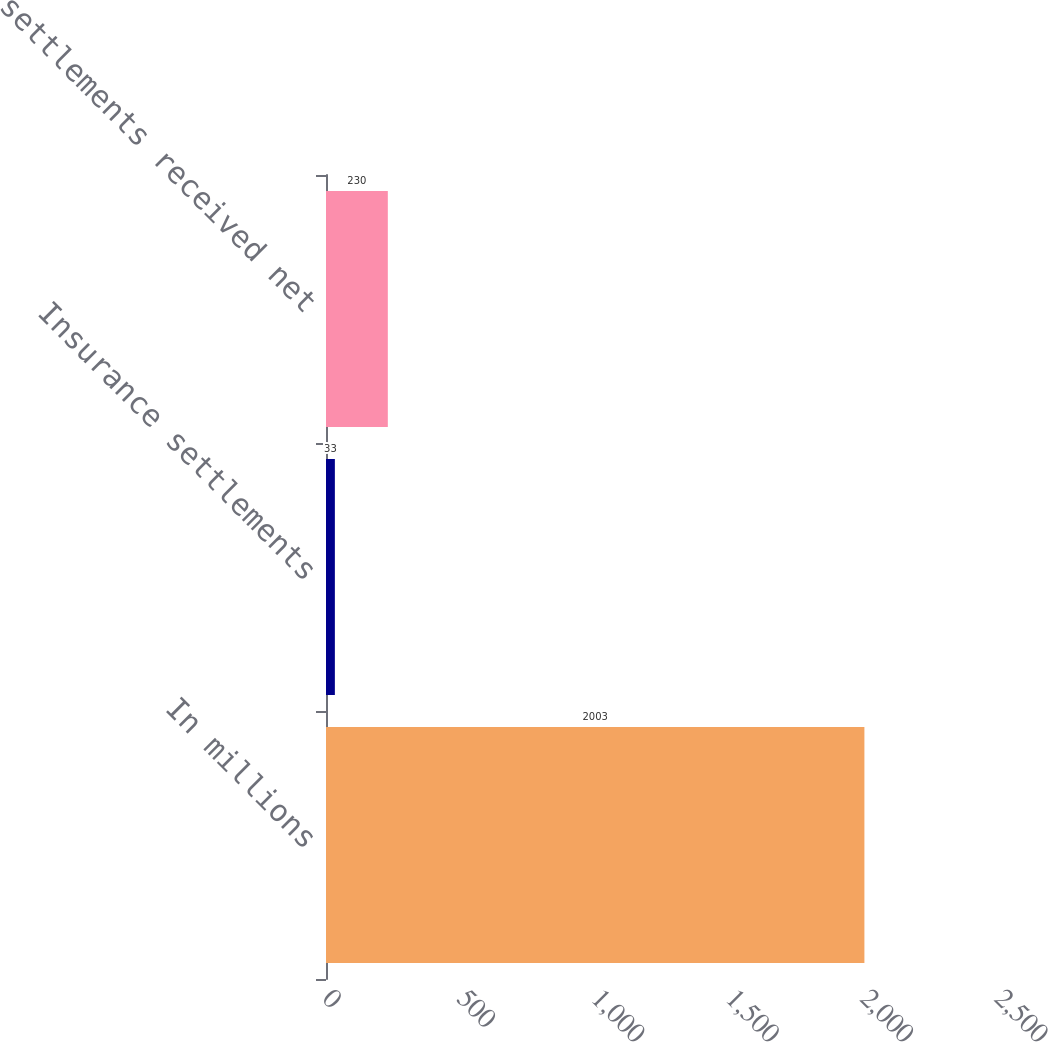Convert chart to OTSL. <chart><loc_0><loc_0><loc_500><loc_500><bar_chart><fcel>In millions<fcel>Insurance settlements<fcel>Cash settlements received net<nl><fcel>2003<fcel>33<fcel>230<nl></chart> 